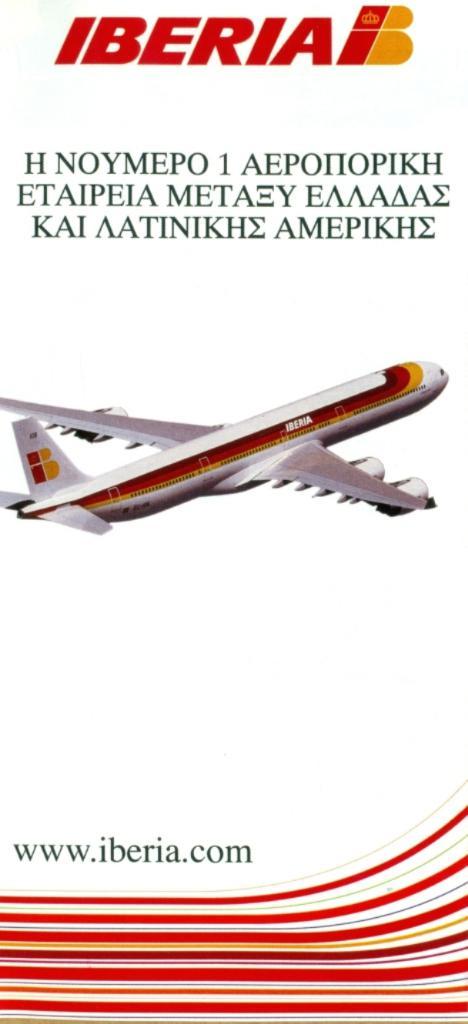What website is printed on the bottom?
Your answer should be compact. Www.iberia.com. What airlines is advertised here?
Provide a short and direct response. Iberia. 